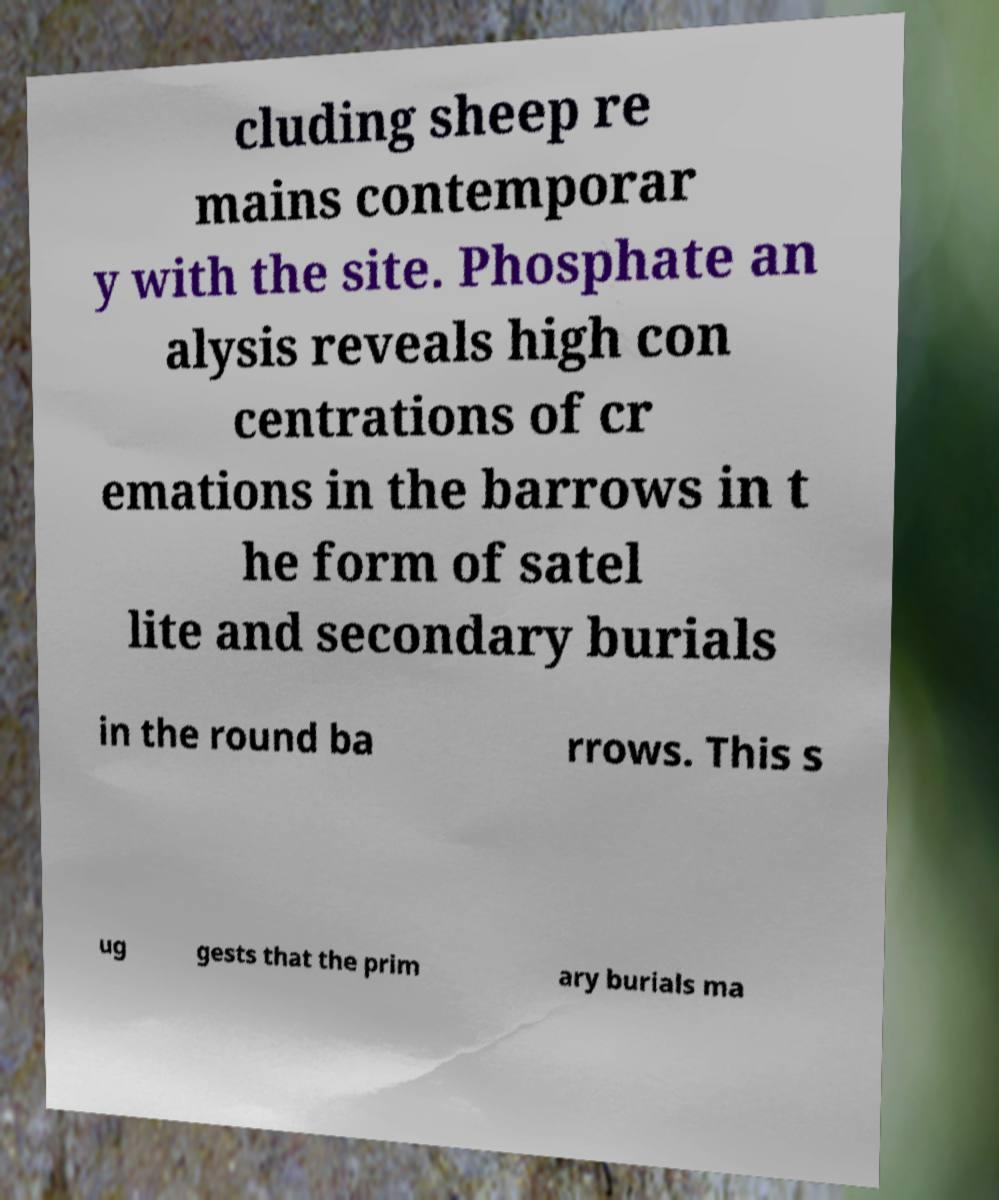For documentation purposes, I need the text within this image transcribed. Could you provide that? cluding sheep re mains contemporar y with the site. Phosphate an alysis reveals high con centrations of cr emations in the barrows in t he form of satel lite and secondary burials in the round ba rrows. This s ug gests that the prim ary burials ma 